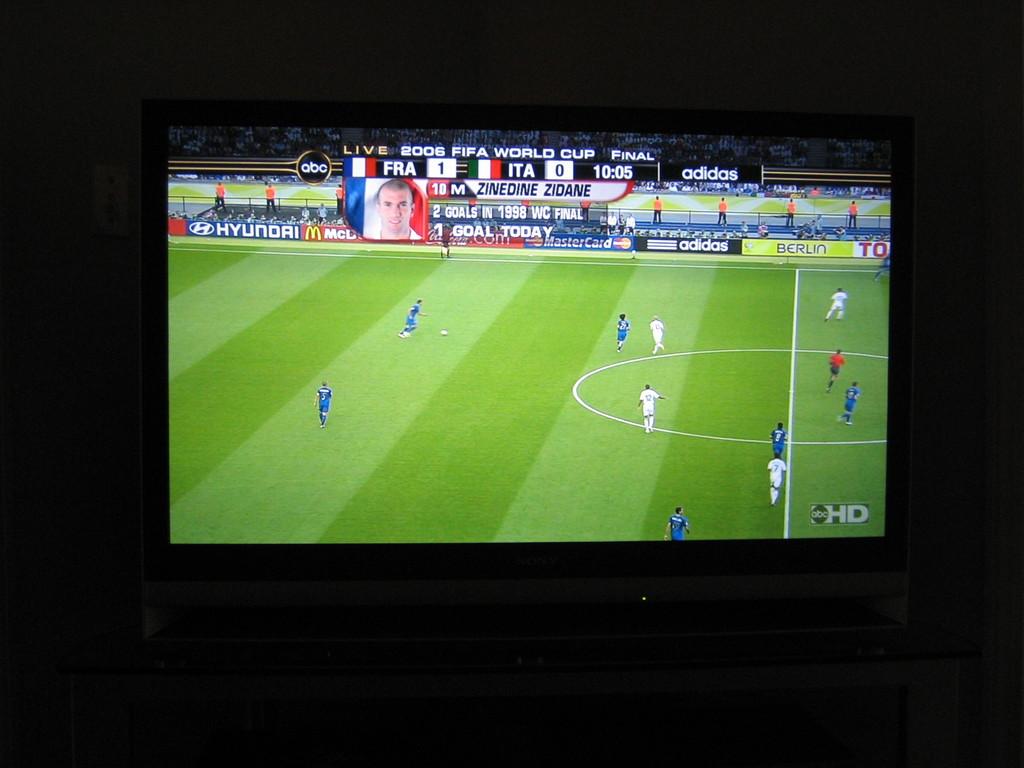How many goals does france have?
Give a very brief answer. 1. What is the score?
Your response must be concise. 1-0. 